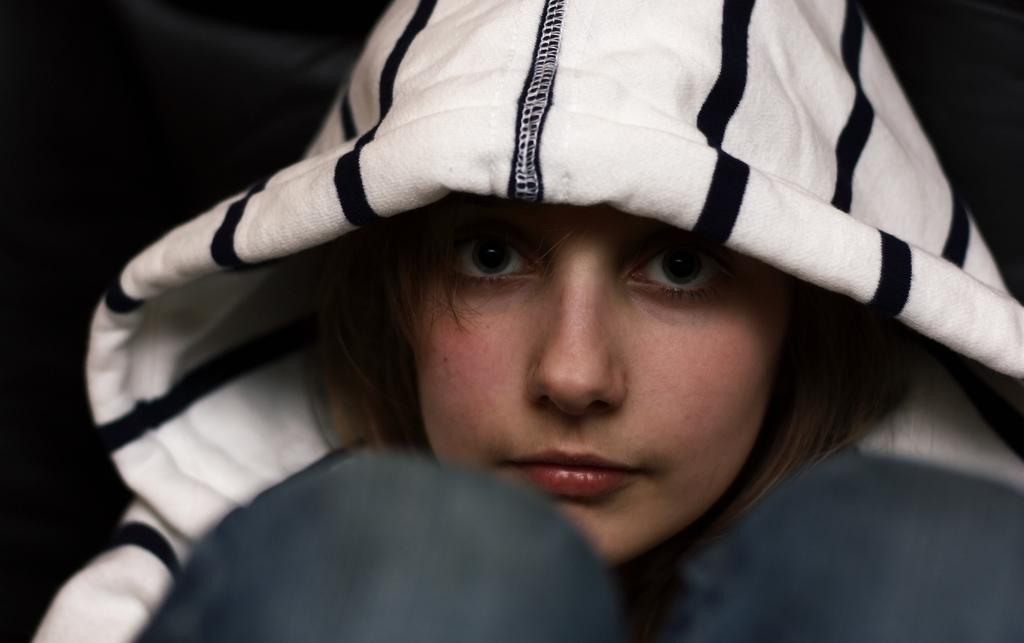Who or what is the main subject of the image? There is a person in the image. What type of clothing is the person wearing? The person is wearing a hoodie. Can you describe the background of the image? The background of the image is dark. What type of stone can be seen in the person's jeans in the image? There is no stone or jeans present in the image; the person is wearing a hoodie. What type of slave is depicted in the image? There is no depiction of a slave in the image; it features a person wearing a hoodie. 